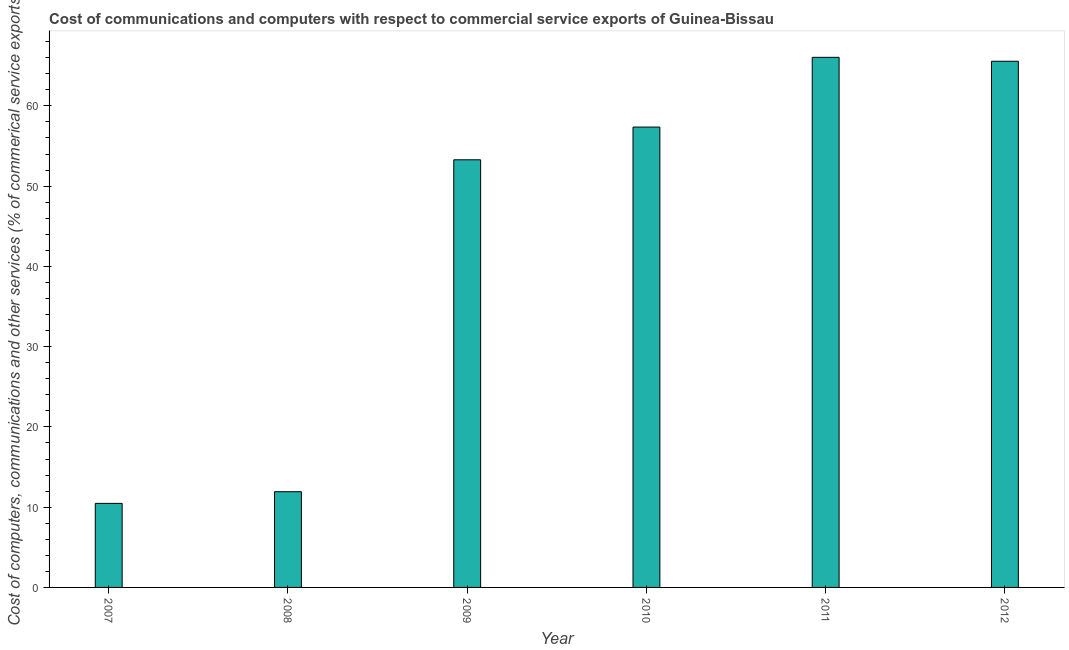Does the graph contain any zero values?
Provide a succinct answer. No. What is the title of the graph?
Your answer should be very brief. Cost of communications and computers with respect to commercial service exports of Guinea-Bissau. What is the label or title of the Y-axis?
Offer a very short reply. Cost of computers, communications and other services (% of commerical service exports). What is the cost of communications in 2012?
Offer a terse response. 65.56. Across all years, what is the maximum cost of communications?
Your response must be concise. 66.05. Across all years, what is the minimum cost of communications?
Offer a terse response. 10.47. In which year was the  computer and other services maximum?
Offer a terse response. 2011. What is the sum of the cost of communications?
Keep it short and to the point. 264.64. What is the difference between the cost of communications in 2010 and 2011?
Your answer should be compact. -8.69. What is the average cost of communications per year?
Ensure brevity in your answer.  44.11. What is the median  computer and other services?
Your response must be concise. 55.32. In how many years, is the  computer and other services greater than 46 %?
Provide a succinct answer. 4. What is the ratio of the  computer and other services in 2009 to that in 2010?
Your answer should be very brief. 0.93. Is the cost of communications in 2008 less than that in 2009?
Keep it short and to the point. Yes. Is the difference between the  computer and other services in 2008 and 2012 greater than the difference between any two years?
Ensure brevity in your answer.  No. What is the difference between the highest and the second highest cost of communications?
Your response must be concise. 0.49. What is the difference between the highest and the lowest  computer and other services?
Provide a short and direct response. 55.58. In how many years, is the  computer and other services greater than the average  computer and other services taken over all years?
Offer a terse response. 4. How many bars are there?
Your response must be concise. 6. How many years are there in the graph?
Ensure brevity in your answer.  6. What is the Cost of computers, communications and other services (% of commerical service exports) in 2007?
Provide a short and direct response. 10.47. What is the Cost of computers, communications and other services (% of commerical service exports) in 2008?
Give a very brief answer. 11.93. What is the Cost of computers, communications and other services (% of commerical service exports) in 2009?
Keep it short and to the point. 53.28. What is the Cost of computers, communications and other services (% of commerical service exports) in 2010?
Offer a very short reply. 57.36. What is the Cost of computers, communications and other services (% of commerical service exports) in 2011?
Make the answer very short. 66.05. What is the Cost of computers, communications and other services (% of commerical service exports) of 2012?
Your response must be concise. 65.56. What is the difference between the Cost of computers, communications and other services (% of commerical service exports) in 2007 and 2008?
Give a very brief answer. -1.45. What is the difference between the Cost of computers, communications and other services (% of commerical service exports) in 2007 and 2009?
Ensure brevity in your answer.  -42.81. What is the difference between the Cost of computers, communications and other services (% of commerical service exports) in 2007 and 2010?
Provide a short and direct response. -46.89. What is the difference between the Cost of computers, communications and other services (% of commerical service exports) in 2007 and 2011?
Offer a very short reply. -55.58. What is the difference between the Cost of computers, communications and other services (% of commerical service exports) in 2007 and 2012?
Give a very brief answer. -55.09. What is the difference between the Cost of computers, communications and other services (% of commerical service exports) in 2008 and 2009?
Your response must be concise. -41.36. What is the difference between the Cost of computers, communications and other services (% of commerical service exports) in 2008 and 2010?
Provide a succinct answer. -45.43. What is the difference between the Cost of computers, communications and other services (% of commerical service exports) in 2008 and 2011?
Offer a terse response. -54.12. What is the difference between the Cost of computers, communications and other services (% of commerical service exports) in 2008 and 2012?
Make the answer very short. -53.63. What is the difference between the Cost of computers, communications and other services (% of commerical service exports) in 2009 and 2010?
Give a very brief answer. -4.08. What is the difference between the Cost of computers, communications and other services (% of commerical service exports) in 2009 and 2011?
Keep it short and to the point. -12.77. What is the difference between the Cost of computers, communications and other services (% of commerical service exports) in 2009 and 2012?
Your answer should be very brief. -12.28. What is the difference between the Cost of computers, communications and other services (% of commerical service exports) in 2010 and 2011?
Keep it short and to the point. -8.69. What is the difference between the Cost of computers, communications and other services (% of commerical service exports) in 2010 and 2012?
Your answer should be very brief. -8.2. What is the difference between the Cost of computers, communications and other services (% of commerical service exports) in 2011 and 2012?
Your answer should be compact. 0.49. What is the ratio of the Cost of computers, communications and other services (% of commerical service exports) in 2007 to that in 2008?
Make the answer very short. 0.88. What is the ratio of the Cost of computers, communications and other services (% of commerical service exports) in 2007 to that in 2009?
Give a very brief answer. 0.2. What is the ratio of the Cost of computers, communications and other services (% of commerical service exports) in 2007 to that in 2010?
Provide a succinct answer. 0.18. What is the ratio of the Cost of computers, communications and other services (% of commerical service exports) in 2007 to that in 2011?
Offer a very short reply. 0.16. What is the ratio of the Cost of computers, communications and other services (% of commerical service exports) in 2007 to that in 2012?
Give a very brief answer. 0.16. What is the ratio of the Cost of computers, communications and other services (% of commerical service exports) in 2008 to that in 2009?
Provide a succinct answer. 0.22. What is the ratio of the Cost of computers, communications and other services (% of commerical service exports) in 2008 to that in 2010?
Offer a terse response. 0.21. What is the ratio of the Cost of computers, communications and other services (% of commerical service exports) in 2008 to that in 2011?
Offer a very short reply. 0.18. What is the ratio of the Cost of computers, communications and other services (% of commerical service exports) in 2008 to that in 2012?
Provide a succinct answer. 0.18. What is the ratio of the Cost of computers, communications and other services (% of commerical service exports) in 2009 to that in 2010?
Provide a succinct answer. 0.93. What is the ratio of the Cost of computers, communications and other services (% of commerical service exports) in 2009 to that in 2011?
Your answer should be very brief. 0.81. What is the ratio of the Cost of computers, communications and other services (% of commerical service exports) in 2009 to that in 2012?
Give a very brief answer. 0.81. What is the ratio of the Cost of computers, communications and other services (% of commerical service exports) in 2010 to that in 2011?
Your answer should be very brief. 0.87. 